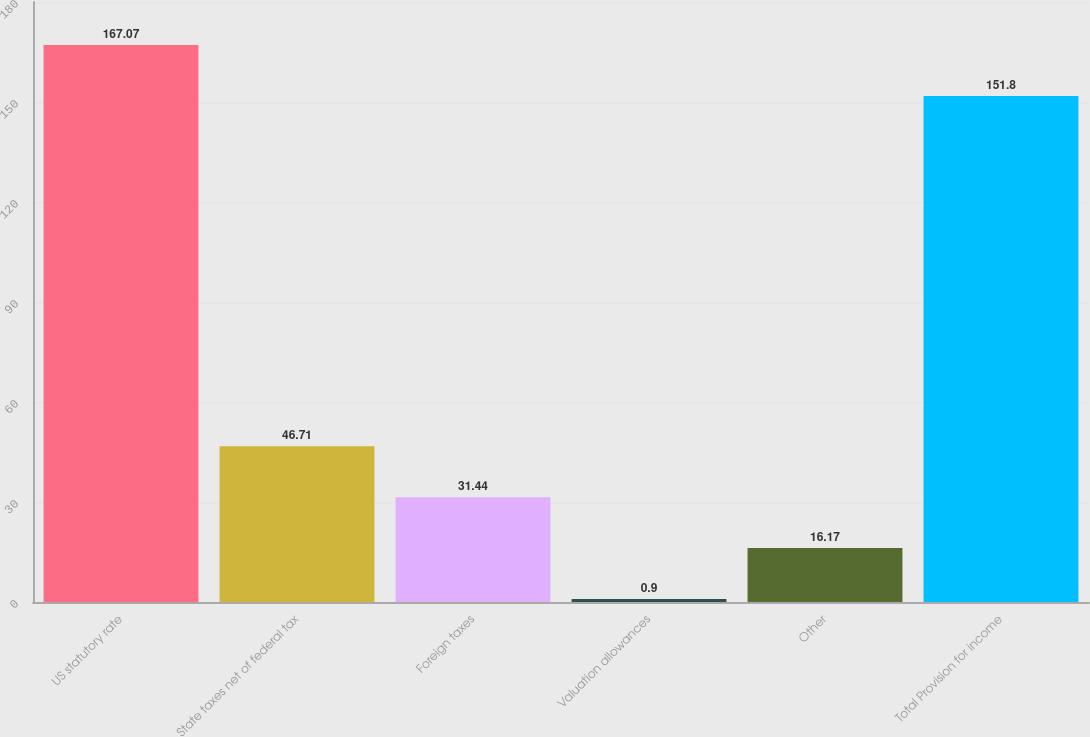Convert chart to OTSL. <chart><loc_0><loc_0><loc_500><loc_500><bar_chart><fcel>US statutory rate<fcel>State taxes net of federal tax<fcel>Foreign taxes<fcel>Valuation allowances<fcel>Other<fcel>Total Provision for income<nl><fcel>167.07<fcel>46.71<fcel>31.44<fcel>0.9<fcel>16.17<fcel>151.8<nl></chart> 